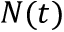Convert formula to latex. <formula><loc_0><loc_0><loc_500><loc_500>N ( t )</formula> 